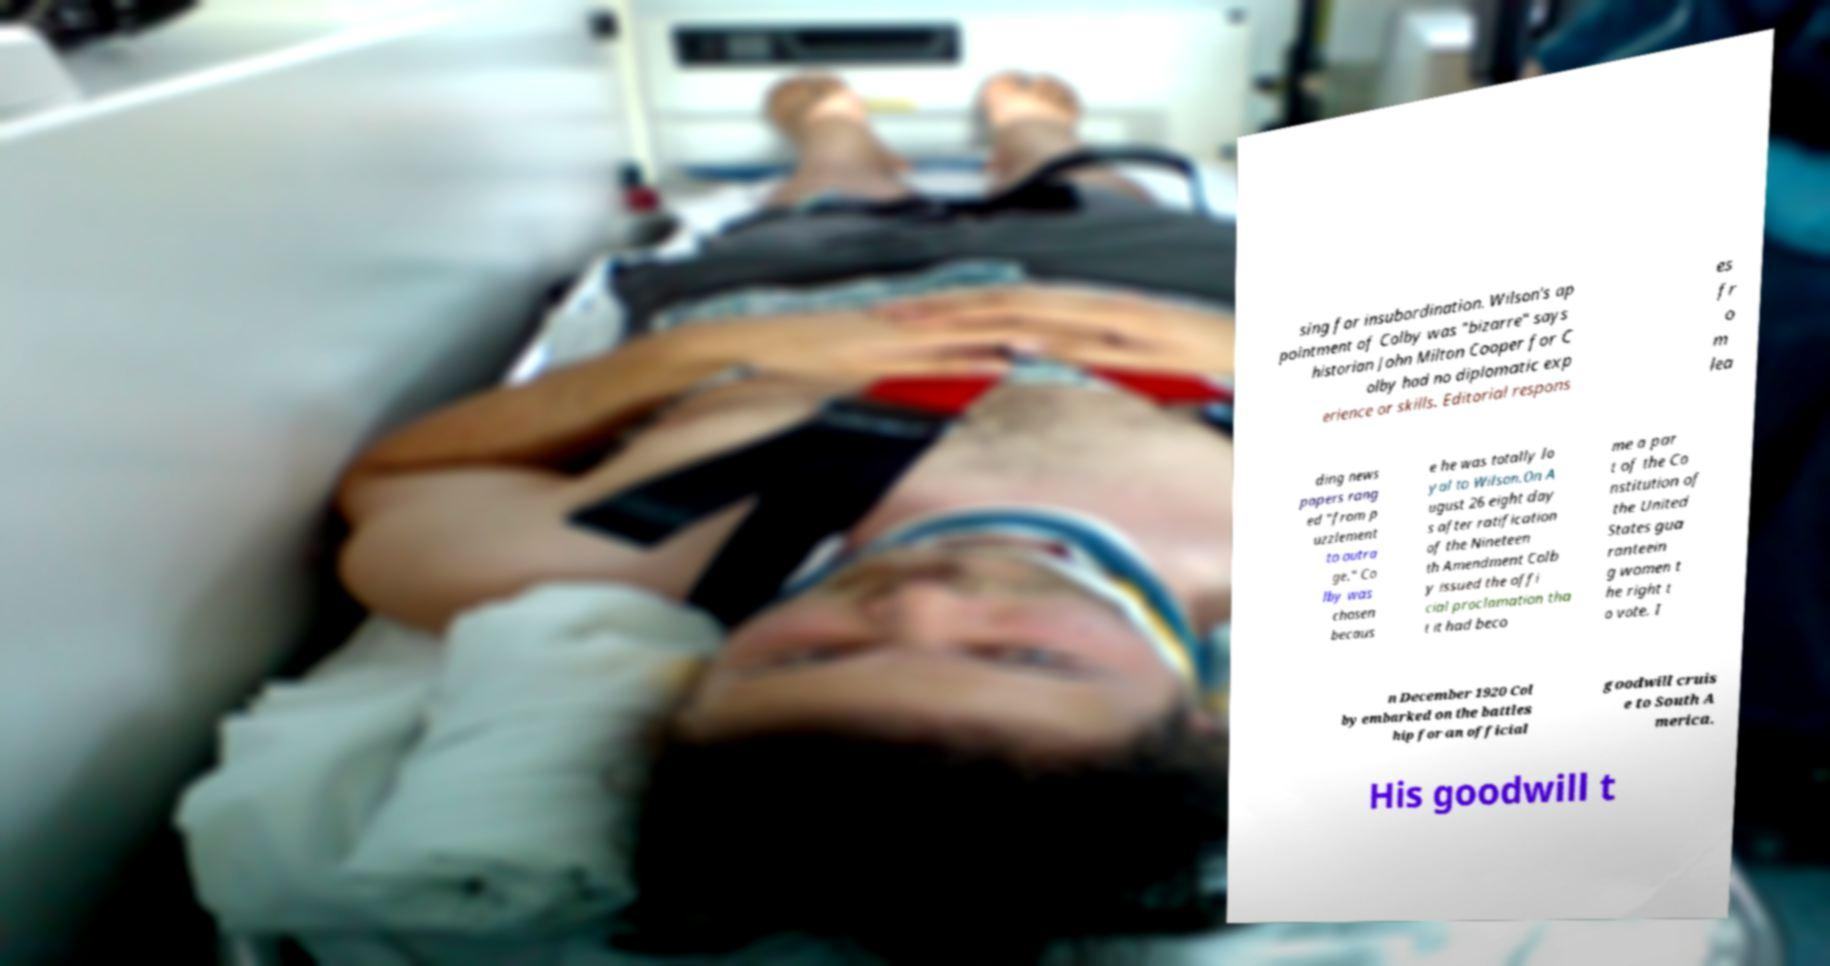Could you assist in decoding the text presented in this image and type it out clearly? sing for insubordination. Wilson's ap pointment of Colby was "bizarre" says historian John Milton Cooper for C olby had no diplomatic exp erience or skills. Editorial respons es fr o m lea ding news papers rang ed "from p uzzlement to outra ge." Co lby was chosen becaus e he was totally lo yal to Wilson.On A ugust 26 eight day s after ratification of the Nineteen th Amendment Colb y issued the offi cial proclamation tha t it had beco me a par t of the Co nstitution of the United States gua ranteein g women t he right t o vote. I n December 1920 Col by embarked on the battles hip for an official goodwill cruis e to South A merica. His goodwill t 